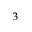Convert formula to latex. <formula><loc_0><loc_0><loc_500><loc_500>^ { 3 }</formula> 